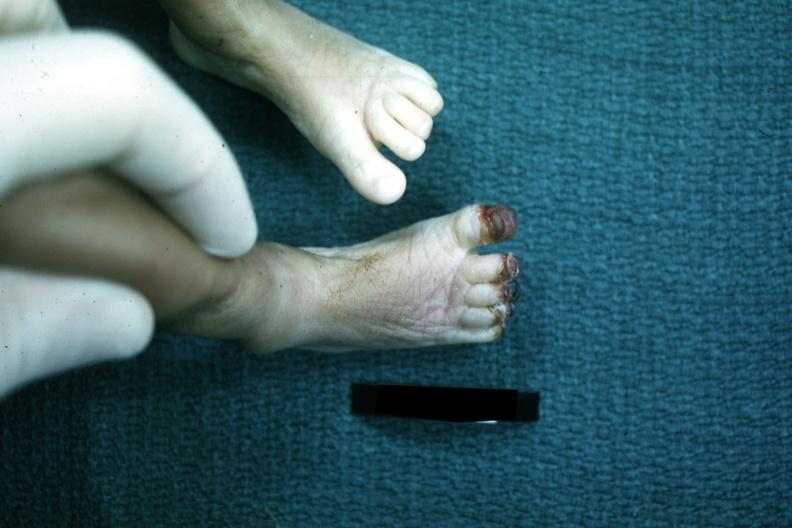what are present?
Answer the question using a single word or phrase. Extremities 